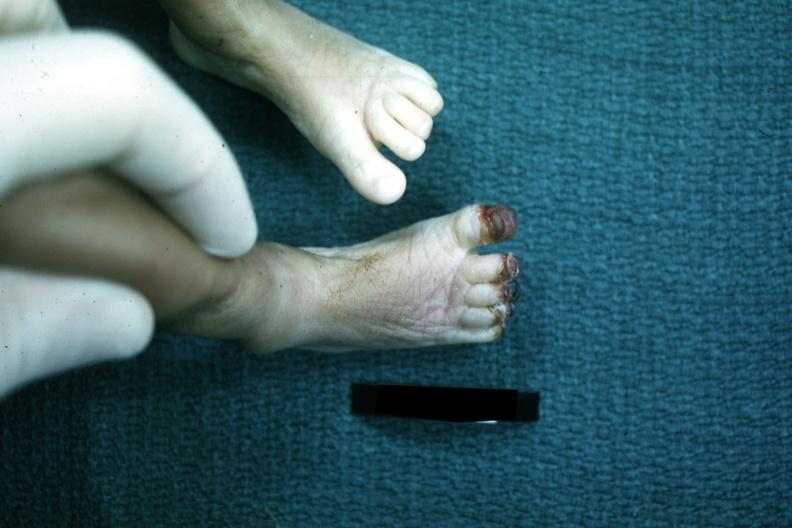what are present?
Answer the question using a single word or phrase. Extremities 